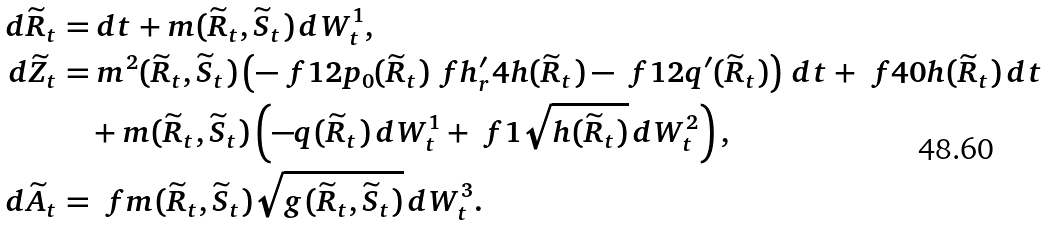Convert formula to latex. <formula><loc_0><loc_0><loc_500><loc_500>d { \widetilde { R } } _ { t } & = d t + m ( { \widetilde { R } } _ { t } , { \widetilde { S } } _ { t } ) \, d W _ { t } ^ { 1 } , \\ d { \widetilde { Z } } _ { t } & = m ^ { 2 } ( { \widetilde { R } } _ { t } , { \widetilde { S } } _ { t } ) \left ( - \ f 1 2 p _ { 0 } ( { \widetilde { R } } _ { t } ) \ f { h ^ { \prime } _ { r } } { 4 h } ( { \widetilde { R } } _ { t } ) - \ f 1 2 q ^ { \prime } ( { \widetilde { R } } _ { t } ) \right ) \, d t + \ f { 4 0 } { h ( \widetilde { R } _ { t } ) } \, d t \\ & \quad + m ( { \widetilde { R } } _ { t } , { \widetilde { S } } _ { t } ) \left ( - q ( { \widetilde { R } } _ { t } ) \, d W _ { t } ^ { 1 } + \ f { 1 } { \sqrt { h ( { \widetilde { R } } _ { t } ) } } \, d W _ { t } ^ { 2 } \right ) , \\ d { \widetilde { A } } _ { t } & = \ f { m ( { \widetilde { R } } _ { t } , { \widetilde { S } } _ { t } ) } { \sqrt { g ( { \widetilde { R } } _ { t } , { \widetilde { S } } _ { t } ) } } \, d W ^ { 3 } _ { t } .</formula> 